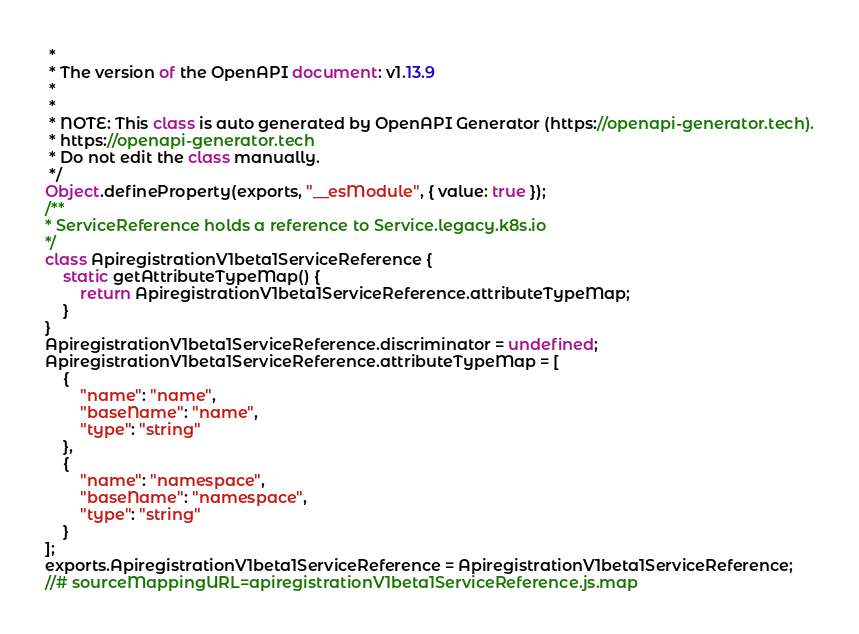Convert code to text. <code><loc_0><loc_0><loc_500><loc_500><_JavaScript_> *
 * The version of the OpenAPI document: v1.13.9
 *
 *
 * NOTE: This class is auto generated by OpenAPI Generator (https://openapi-generator.tech).
 * https://openapi-generator.tech
 * Do not edit the class manually.
 */
Object.defineProperty(exports, "__esModule", { value: true });
/**
* ServiceReference holds a reference to Service.legacy.k8s.io
*/
class ApiregistrationV1beta1ServiceReference {
    static getAttributeTypeMap() {
        return ApiregistrationV1beta1ServiceReference.attributeTypeMap;
    }
}
ApiregistrationV1beta1ServiceReference.discriminator = undefined;
ApiregistrationV1beta1ServiceReference.attributeTypeMap = [
    {
        "name": "name",
        "baseName": "name",
        "type": "string"
    },
    {
        "name": "namespace",
        "baseName": "namespace",
        "type": "string"
    }
];
exports.ApiregistrationV1beta1ServiceReference = ApiregistrationV1beta1ServiceReference;
//# sourceMappingURL=apiregistrationV1beta1ServiceReference.js.map</code> 